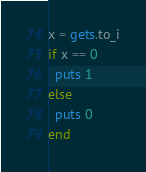<code> <loc_0><loc_0><loc_500><loc_500><_Ruby_>x = gets.to_i
if x == 0
  puts 1
else
  puts 0
end
</code> 